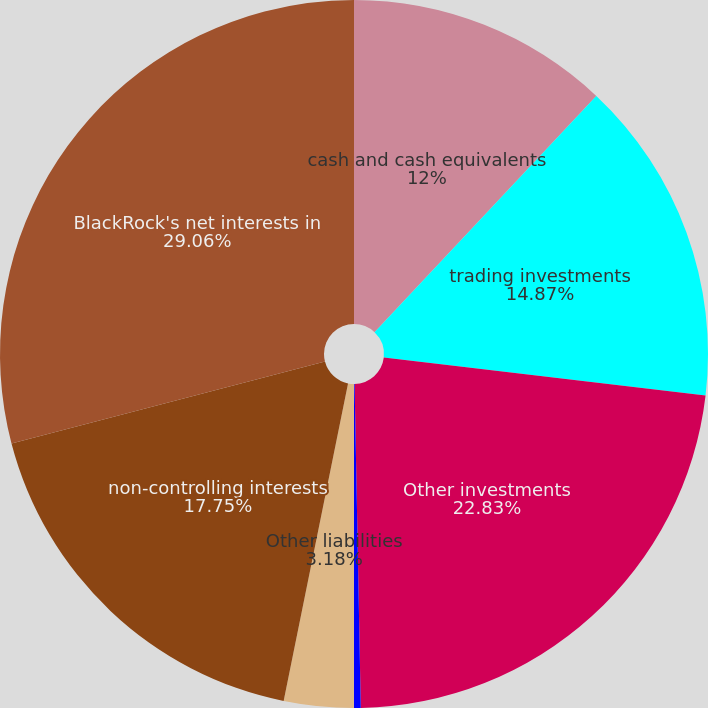Convert chart to OTSL. <chart><loc_0><loc_0><loc_500><loc_500><pie_chart><fcel>cash and cash equivalents<fcel>trading investments<fcel>Other investments<fcel>Other assets<fcel>Other liabilities<fcel>non-controlling interests<fcel>BlackRock's net interests in<nl><fcel>12.0%<fcel>14.87%<fcel>22.83%<fcel>0.31%<fcel>3.18%<fcel>17.75%<fcel>29.07%<nl></chart> 